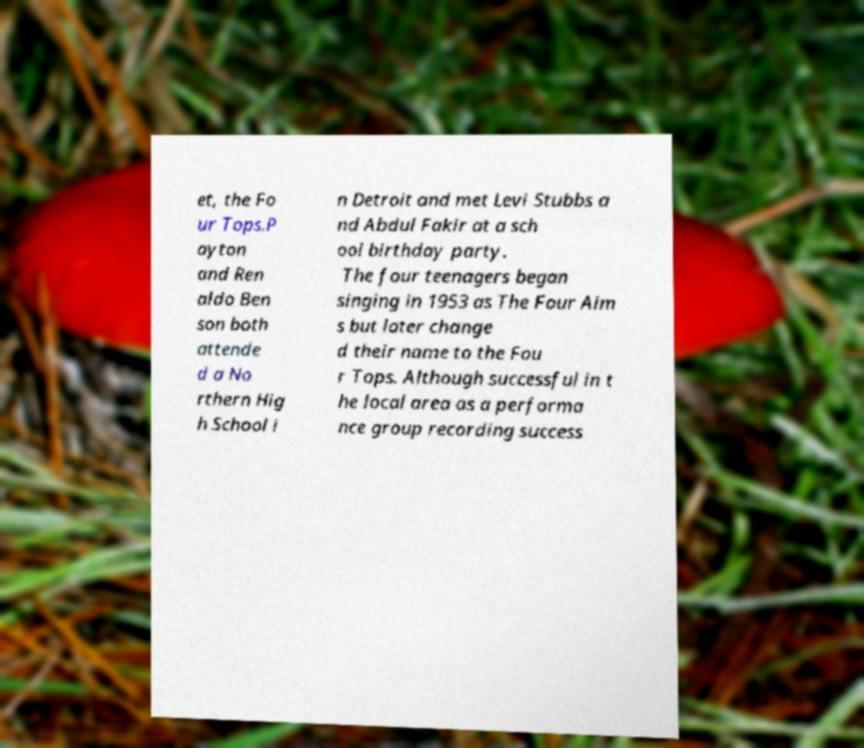Can you read and provide the text displayed in the image?This photo seems to have some interesting text. Can you extract and type it out for me? et, the Fo ur Tops.P ayton and Ren aldo Ben son both attende d a No rthern Hig h School i n Detroit and met Levi Stubbs a nd Abdul Fakir at a sch ool birthday party. The four teenagers began singing in 1953 as The Four Aim s but later change d their name to the Fou r Tops. Although successful in t he local area as a performa nce group recording success 